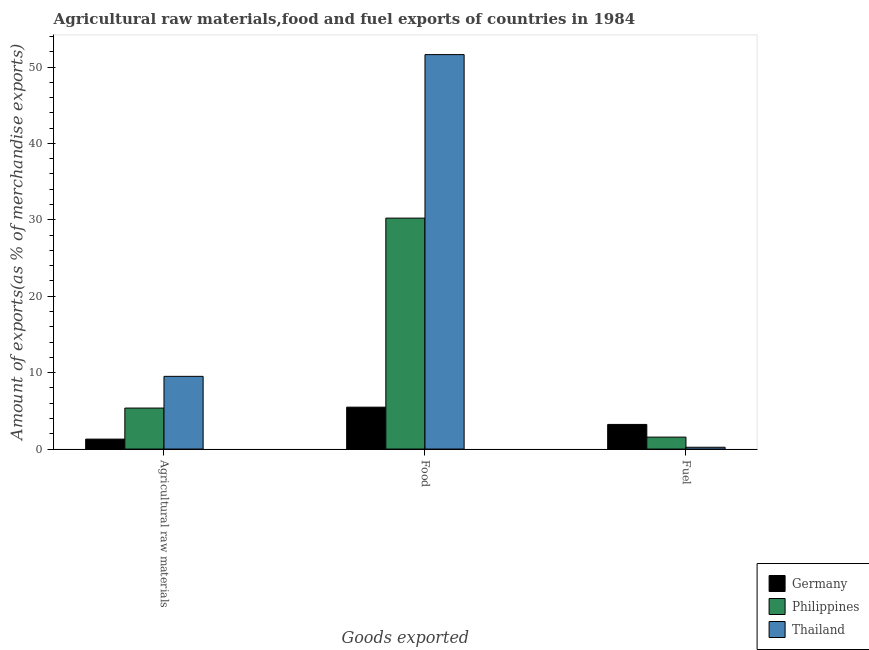How many different coloured bars are there?
Keep it short and to the point. 3. What is the label of the 3rd group of bars from the left?
Make the answer very short. Fuel. What is the percentage of raw materials exports in Philippines?
Provide a short and direct response. 5.37. Across all countries, what is the maximum percentage of fuel exports?
Keep it short and to the point. 3.23. Across all countries, what is the minimum percentage of food exports?
Provide a succinct answer. 5.49. In which country was the percentage of food exports minimum?
Offer a very short reply. Germany. What is the total percentage of fuel exports in the graph?
Offer a very short reply. 5.03. What is the difference between the percentage of fuel exports in Germany and that in Thailand?
Your answer should be compact. 2.99. What is the difference between the percentage of raw materials exports in Germany and the percentage of fuel exports in Philippines?
Give a very brief answer. -0.26. What is the average percentage of raw materials exports per country?
Ensure brevity in your answer.  5.4. What is the difference between the percentage of raw materials exports and percentage of fuel exports in Philippines?
Offer a terse response. 3.8. What is the ratio of the percentage of raw materials exports in Philippines to that in Germany?
Offer a terse response. 4.12. Is the percentage of fuel exports in Thailand less than that in Philippines?
Provide a short and direct response. Yes. Is the difference between the percentage of fuel exports in Germany and Philippines greater than the difference between the percentage of raw materials exports in Germany and Philippines?
Make the answer very short. Yes. What is the difference between the highest and the second highest percentage of food exports?
Ensure brevity in your answer.  21.4. What is the difference between the highest and the lowest percentage of raw materials exports?
Offer a terse response. 8.21. In how many countries, is the percentage of raw materials exports greater than the average percentage of raw materials exports taken over all countries?
Make the answer very short. 1. What does the 1st bar from the right in Fuel represents?
Your answer should be compact. Thailand. Is it the case that in every country, the sum of the percentage of raw materials exports and percentage of food exports is greater than the percentage of fuel exports?
Your response must be concise. Yes. Does the graph contain grids?
Make the answer very short. No. How many legend labels are there?
Your answer should be very brief. 3. What is the title of the graph?
Offer a terse response. Agricultural raw materials,food and fuel exports of countries in 1984. Does "Sudan" appear as one of the legend labels in the graph?
Ensure brevity in your answer.  No. What is the label or title of the X-axis?
Your answer should be very brief. Goods exported. What is the label or title of the Y-axis?
Your answer should be compact. Amount of exports(as % of merchandise exports). What is the Amount of exports(as % of merchandise exports) in Germany in Agricultural raw materials?
Your response must be concise. 1.3. What is the Amount of exports(as % of merchandise exports) in Philippines in Agricultural raw materials?
Ensure brevity in your answer.  5.37. What is the Amount of exports(as % of merchandise exports) of Thailand in Agricultural raw materials?
Provide a succinct answer. 9.52. What is the Amount of exports(as % of merchandise exports) in Germany in Food?
Make the answer very short. 5.49. What is the Amount of exports(as % of merchandise exports) in Philippines in Food?
Make the answer very short. 30.23. What is the Amount of exports(as % of merchandise exports) of Thailand in Food?
Your response must be concise. 51.63. What is the Amount of exports(as % of merchandise exports) in Germany in Fuel?
Make the answer very short. 3.23. What is the Amount of exports(as % of merchandise exports) in Philippines in Fuel?
Ensure brevity in your answer.  1.57. What is the Amount of exports(as % of merchandise exports) of Thailand in Fuel?
Make the answer very short. 0.24. Across all Goods exported, what is the maximum Amount of exports(as % of merchandise exports) in Germany?
Your answer should be very brief. 5.49. Across all Goods exported, what is the maximum Amount of exports(as % of merchandise exports) in Philippines?
Ensure brevity in your answer.  30.23. Across all Goods exported, what is the maximum Amount of exports(as % of merchandise exports) in Thailand?
Your answer should be very brief. 51.63. Across all Goods exported, what is the minimum Amount of exports(as % of merchandise exports) in Germany?
Your response must be concise. 1.3. Across all Goods exported, what is the minimum Amount of exports(as % of merchandise exports) in Philippines?
Provide a short and direct response. 1.57. Across all Goods exported, what is the minimum Amount of exports(as % of merchandise exports) in Thailand?
Ensure brevity in your answer.  0.24. What is the total Amount of exports(as % of merchandise exports) in Germany in the graph?
Provide a short and direct response. 10.02. What is the total Amount of exports(as % of merchandise exports) of Philippines in the graph?
Keep it short and to the point. 37.16. What is the total Amount of exports(as % of merchandise exports) of Thailand in the graph?
Keep it short and to the point. 61.38. What is the difference between the Amount of exports(as % of merchandise exports) of Germany in Agricultural raw materials and that in Food?
Keep it short and to the point. -4.18. What is the difference between the Amount of exports(as % of merchandise exports) in Philippines in Agricultural raw materials and that in Food?
Your answer should be compact. -24.86. What is the difference between the Amount of exports(as % of merchandise exports) of Thailand in Agricultural raw materials and that in Food?
Your answer should be compact. -42.11. What is the difference between the Amount of exports(as % of merchandise exports) in Germany in Agricultural raw materials and that in Fuel?
Ensure brevity in your answer.  -1.92. What is the difference between the Amount of exports(as % of merchandise exports) in Philippines in Agricultural raw materials and that in Fuel?
Provide a succinct answer. 3.8. What is the difference between the Amount of exports(as % of merchandise exports) of Thailand in Agricultural raw materials and that in Fuel?
Provide a short and direct response. 9.28. What is the difference between the Amount of exports(as % of merchandise exports) of Germany in Food and that in Fuel?
Keep it short and to the point. 2.26. What is the difference between the Amount of exports(as % of merchandise exports) in Philippines in Food and that in Fuel?
Your answer should be compact. 28.66. What is the difference between the Amount of exports(as % of merchandise exports) in Thailand in Food and that in Fuel?
Offer a terse response. 51.39. What is the difference between the Amount of exports(as % of merchandise exports) of Germany in Agricultural raw materials and the Amount of exports(as % of merchandise exports) of Philippines in Food?
Make the answer very short. -28.92. What is the difference between the Amount of exports(as % of merchandise exports) in Germany in Agricultural raw materials and the Amount of exports(as % of merchandise exports) in Thailand in Food?
Your answer should be compact. -50.32. What is the difference between the Amount of exports(as % of merchandise exports) in Philippines in Agricultural raw materials and the Amount of exports(as % of merchandise exports) in Thailand in Food?
Provide a succinct answer. -46.26. What is the difference between the Amount of exports(as % of merchandise exports) in Germany in Agricultural raw materials and the Amount of exports(as % of merchandise exports) in Philippines in Fuel?
Ensure brevity in your answer.  -0.26. What is the difference between the Amount of exports(as % of merchandise exports) of Germany in Agricultural raw materials and the Amount of exports(as % of merchandise exports) of Thailand in Fuel?
Your answer should be very brief. 1.07. What is the difference between the Amount of exports(as % of merchandise exports) in Philippines in Agricultural raw materials and the Amount of exports(as % of merchandise exports) in Thailand in Fuel?
Keep it short and to the point. 5.13. What is the difference between the Amount of exports(as % of merchandise exports) in Germany in Food and the Amount of exports(as % of merchandise exports) in Philippines in Fuel?
Your answer should be compact. 3.92. What is the difference between the Amount of exports(as % of merchandise exports) of Germany in Food and the Amount of exports(as % of merchandise exports) of Thailand in Fuel?
Make the answer very short. 5.25. What is the difference between the Amount of exports(as % of merchandise exports) of Philippines in Food and the Amount of exports(as % of merchandise exports) of Thailand in Fuel?
Ensure brevity in your answer.  29.99. What is the average Amount of exports(as % of merchandise exports) of Germany per Goods exported?
Ensure brevity in your answer.  3.34. What is the average Amount of exports(as % of merchandise exports) of Philippines per Goods exported?
Your answer should be compact. 12.39. What is the average Amount of exports(as % of merchandise exports) of Thailand per Goods exported?
Offer a terse response. 20.46. What is the difference between the Amount of exports(as % of merchandise exports) in Germany and Amount of exports(as % of merchandise exports) in Philippines in Agricultural raw materials?
Give a very brief answer. -4.06. What is the difference between the Amount of exports(as % of merchandise exports) in Germany and Amount of exports(as % of merchandise exports) in Thailand in Agricultural raw materials?
Keep it short and to the point. -8.21. What is the difference between the Amount of exports(as % of merchandise exports) in Philippines and Amount of exports(as % of merchandise exports) in Thailand in Agricultural raw materials?
Provide a succinct answer. -4.15. What is the difference between the Amount of exports(as % of merchandise exports) in Germany and Amount of exports(as % of merchandise exports) in Philippines in Food?
Make the answer very short. -24.74. What is the difference between the Amount of exports(as % of merchandise exports) of Germany and Amount of exports(as % of merchandise exports) of Thailand in Food?
Your answer should be compact. -46.14. What is the difference between the Amount of exports(as % of merchandise exports) in Philippines and Amount of exports(as % of merchandise exports) in Thailand in Food?
Offer a terse response. -21.4. What is the difference between the Amount of exports(as % of merchandise exports) of Germany and Amount of exports(as % of merchandise exports) of Philippines in Fuel?
Give a very brief answer. 1.66. What is the difference between the Amount of exports(as % of merchandise exports) of Germany and Amount of exports(as % of merchandise exports) of Thailand in Fuel?
Keep it short and to the point. 2.99. What is the difference between the Amount of exports(as % of merchandise exports) of Philippines and Amount of exports(as % of merchandise exports) of Thailand in Fuel?
Your response must be concise. 1.33. What is the ratio of the Amount of exports(as % of merchandise exports) of Germany in Agricultural raw materials to that in Food?
Make the answer very short. 0.24. What is the ratio of the Amount of exports(as % of merchandise exports) in Philippines in Agricultural raw materials to that in Food?
Provide a short and direct response. 0.18. What is the ratio of the Amount of exports(as % of merchandise exports) in Thailand in Agricultural raw materials to that in Food?
Keep it short and to the point. 0.18. What is the ratio of the Amount of exports(as % of merchandise exports) in Germany in Agricultural raw materials to that in Fuel?
Provide a succinct answer. 0.4. What is the ratio of the Amount of exports(as % of merchandise exports) of Philippines in Agricultural raw materials to that in Fuel?
Offer a very short reply. 3.43. What is the ratio of the Amount of exports(as % of merchandise exports) in Thailand in Agricultural raw materials to that in Fuel?
Your answer should be very brief. 39.87. What is the ratio of the Amount of exports(as % of merchandise exports) in Germany in Food to that in Fuel?
Provide a succinct answer. 1.7. What is the ratio of the Amount of exports(as % of merchandise exports) in Philippines in Food to that in Fuel?
Your response must be concise. 19.31. What is the ratio of the Amount of exports(as % of merchandise exports) in Thailand in Food to that in Fuel?
Make the answer very short. 216.28. What is the difference between the highest and the second highest Amount of exports(as % of merchandise exports) in Germany?
Offer a very short reply. 2.26. What is the difference between the highest and the second highest Amount of exports(as % of merchandise exports) of Philippines?
Give a very brief answer. 24.86. What is the difference between the highest and the second highest Amount of exports(as % of merchandise exports) of Thailand?
Keep it short and to the point. 42.11. What is the difference between the highest and the lowest Amount of exports(as % of merchandise exports) in Germany?
Keep it short and to the point. 4.18. What is the difference between the highest and the lowest Amount of exports(as % of merchandise exports) of Philippines?
Your answer should be very brief. 28.66. What is the difference between the highest and the lowest Amount of exports(as % of merchandise exports) in Thailand?
Provide a short and direct response. 51.39. 